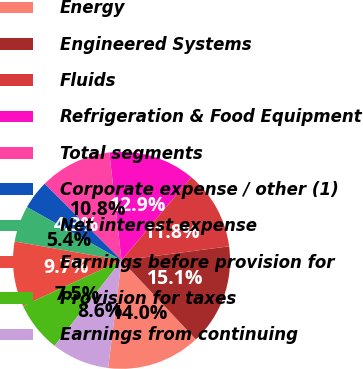<chart> <loc_0><loc_0><loc_500><loc_500><pie_chart><fcel>Energy<fcel>Engineered Systems<fcel>Fluids<fcel>Refrigeration & Food Equipment<fcel>Total segments<fcel>Corporate expense / other (1)<fcel>Net interest expense<fcel>Earnings before provision for<fcel>Provision for taxes<fcel>Earnings from continuing<nl><fcel>13.98%<fcel>15.05%<fcel>11.83%<fcel>12.9%<fcel>10.75%<fcel>4.3%<fcel>5.38%<fcel>9.68%<fcel>7.53%<fcel>8.6%<nl></chart> 